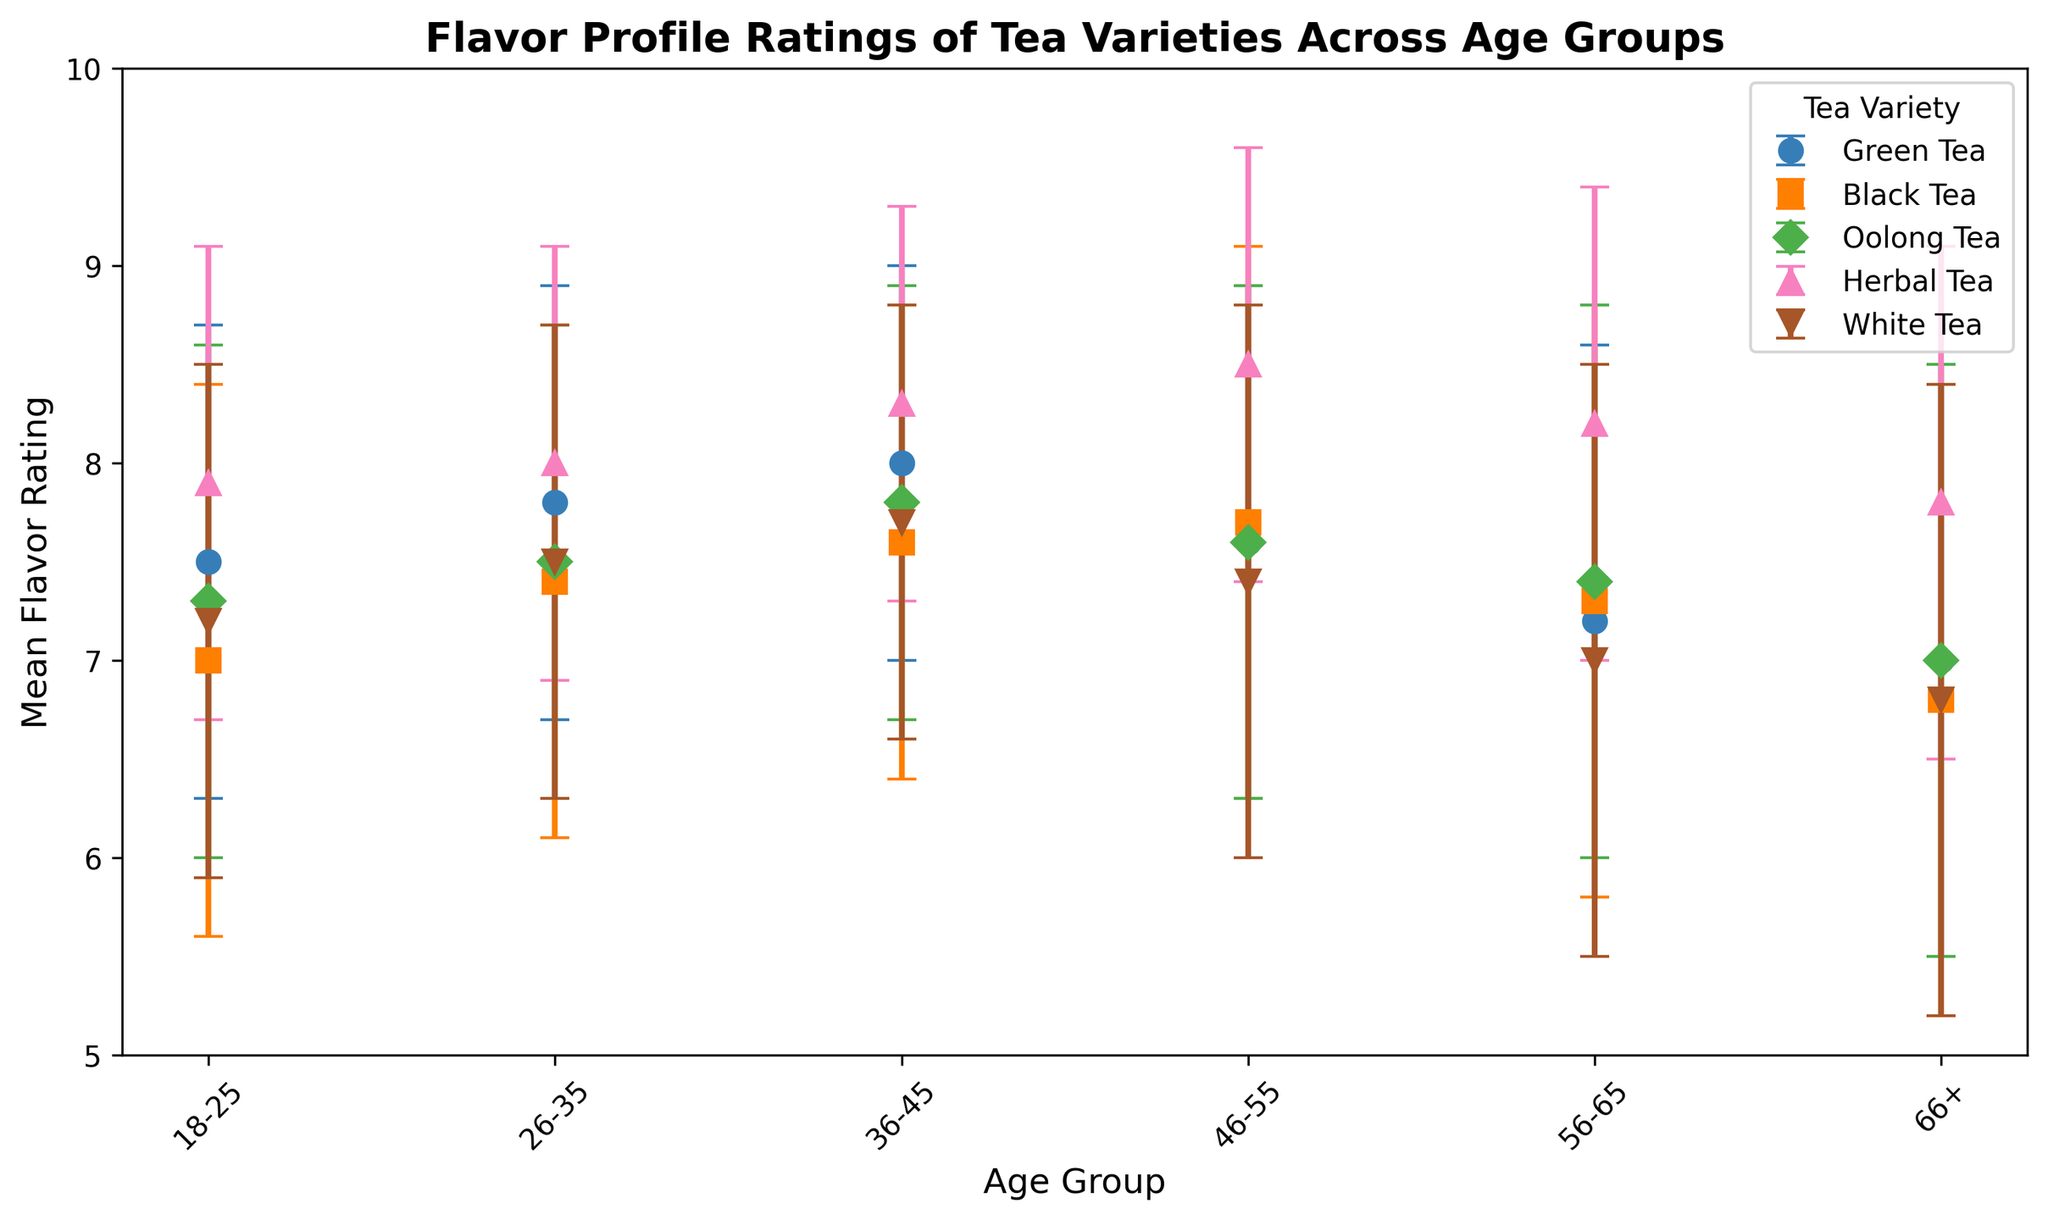Which tea variety has the highest mean flavor rating in the 46-55 age group? The mean flavor ratings for each tea variety in the 46-55 age group are Herbal Tea (8.5), Green Tea (7.6), Black Tea (7.7), Oolong Tea (7.6), and White Tea (7.4). Herbal Tea has the highest rating.
Answer: Herbal Tea Which age group gives the highest mean flavor rating to Herbal Tea? The mean flavor ratings of Herbal Tea by age groups are: 18-25 (7.9), 26-35 (8.0), 36-45 (8.3), 46-55 (8.5), 56-65 (8.2), 66+ (7.8). The 46-55 group gives the highest rating.
Answer: 46-55 What is the average mean flavor rating of Green Tea across all age groups? The mean flavor ratings of Green Tea across the age groups are: 18-25 (7.5), 26-35 (7.8), 36-45 (8.0), 46-55 (7.6), 56-65 (7.2), 66+ (7.0). Adding these gives 45.1, and dividing by 6 gives 7.52.
Answer: 7.52 Which tea variety shows the most decrease in mean flavor rating from the 18-25 age group to the 66+ age group? Calculate the difference in mean flavor ratings from 18-25 to 66+ for each tea: Green Tea (7.5 - 7.0 = 0.5), Black Tea (7.0 - 6.8 = 0.2), Oolong Tea (7.3 - 7.0 = 0.3), Herbal Tea (7.9 - 7.8 = 0.1), White Tea (7.2 - 6.8 = 0.4). White Tea has the most decrease (0.4).
Answer: White Tea Which tea variety has the least standard deviation in its mean flavor ratings within any age group? The lowest standard deviation for mean flavor ratings across any age group is for Green Tea in the 36-45 age group where the standard deviation is 1.0.
Answer: Green Tea Between Black Tea and White Tea, which has a higher mean flavor rating for the age group 56-65? The mean flavor rating of Black Tea for the 56-65 age group is 7.3, and for White Tea is 7.0. Black Tea has the higher rating.
Answer: Black Tea Compare the error bars of Green Tea and Oolong Tea in the 46-55 age group. Which one is larger? The standard deviation for Green Tea in the 46-55 age group is 1.3, and for Oolong Tea is also 1.3. Both have equal error bars.
Answer: Equal Is the trend of mean flavor rating for Oolong Tea increasing or decreasing across the age groups? For Oolong Tea, the mean flavor ratings are: 18-25 (7.3), 26-35 (7.5), 36-45 (7.8), 46-55 (7.6), 56-65 (7.4), 66+ (7.0). Initially increasing until 36-45, then decreasing.
Answer: Increasing then Decreasing Which age group shows the most variability in their mean flavor ratings for any tea variety? The 66+ age group shows the most variability in its mean flavor ratings for Black Tea with a standard deviation of 1.6.
Answer: 66+ How does the mean flavor rating of Herbal Tea in the 36-45 age group compare to the mean flavor rating of Black Tea in the 46-55 age group? The mean flavor rating of Herbal Tea in the 36-45 age group is 8.3. The mean flavor rating of Black Tea in the 46-55 age group is 7.7. Herbal Tea has a higher mean flavor rating.
Answer: Herbal Tea 